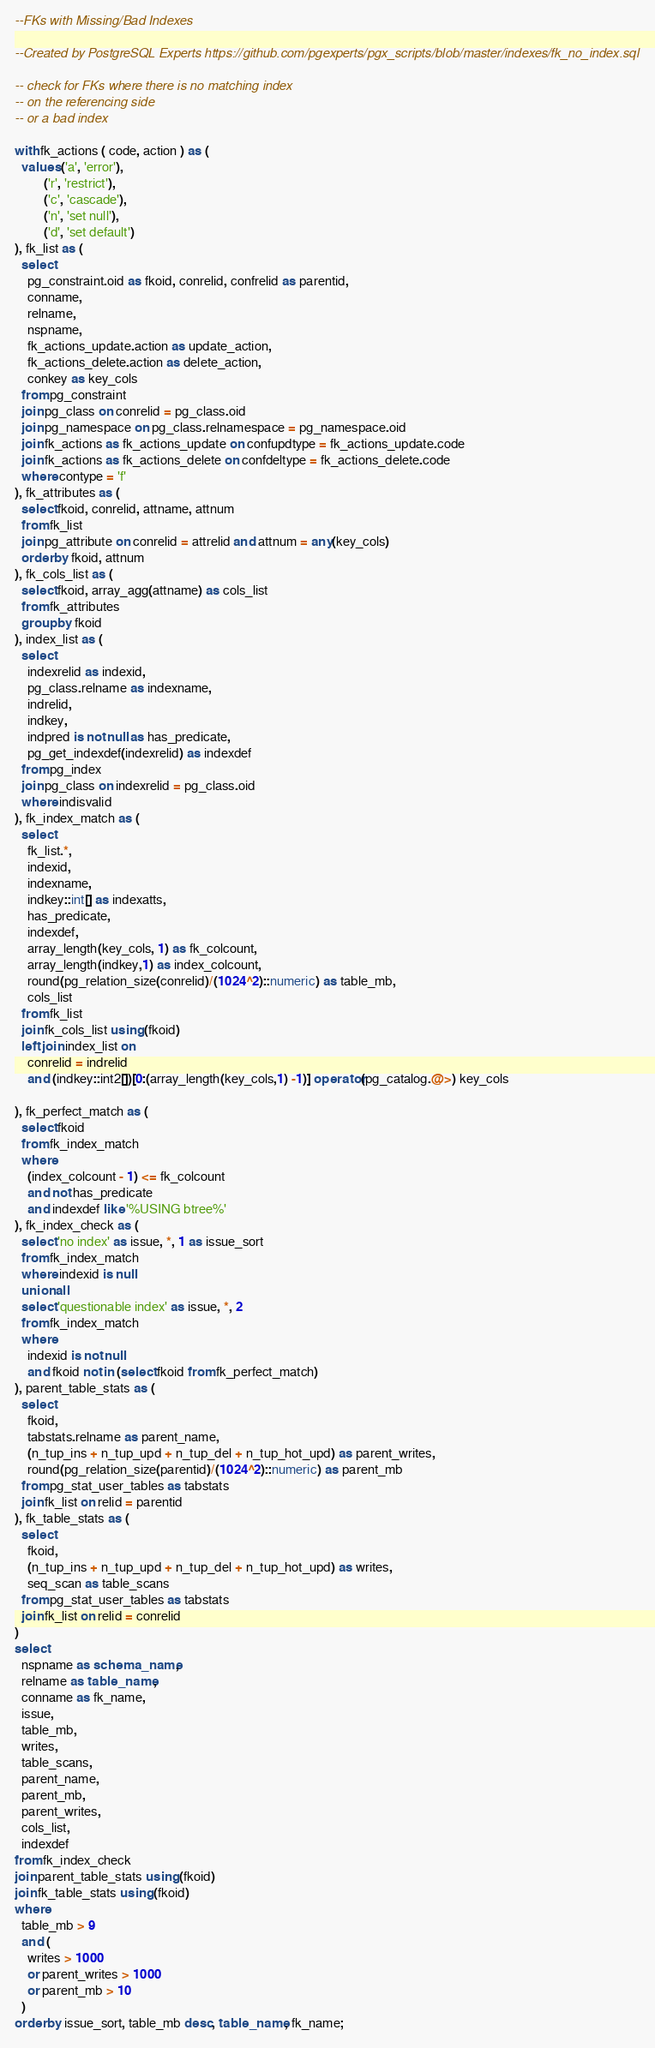Convert code to text. <code><loc_0><loc_0><loc_500><loc_500><_SQL_>--FKs with Missing/Bad Indexes

--Created by PostgreSQL Experts https://github.com/pgexperts/pgx_scripts/blob/master/indexes/fk_no_index.sql

-- check for FKs where there is no matching index
-- on the referencing side
-- or a bad index

with fk_actions ( code, action ) as (
  values ('a', 'error'),
         ('r', 'restrict'),
         ('c', 'cascade'),
         ('n', 'set null'),
         ('d', 'set default')
), fk_list as (
  select
    pg_constraint.oid as fkoid, conrelid, confrelid as parentid,
    conname,
    relname,
    nspname,
    fk_actions_update.action as update_action,
    fk_actions_delete.action as delete_action,
    conkey as key_cols
  from pg_constraint
  join pg_class on conrelid = pg_class.oid
  join pg_namespace on pg_class.relnamespace = pg_namespace.oid
  join fk_actions as fk_actions_update on confupdtype = fk_actions_update.code
  join fk_actions as fk_actions_delete on confdeltype = fk_actions_delete.code
  where contype = 'f'
), fk_attributes as (
  select fkoid, conrelid, attname, attnum
  from fk_list
  join pg_attribute on conrelid = attrelid and attnum = any(key_cols)
  order by fkoid, attnum
), fk_cols_list as (
  select fkoid, array_agg(attname) as cols_list
  from fk_attributes
  group by fkoid
), index_list as (
  select
    indexrelid as indexid,
    pg_class.relname as indexname,
    indrelid,
    indkey,
    indpred is not null as has_predicate,
    pg_get_indexdef(indexrelid) as indexdef
  from pg_index
  join pg_class on indexrelid = pg_class.oid
  where indisvalid
), fk_index_match as (
  select
    fk_list.*,
    indexid,
    indexname,
    indkey::int[] as indexatts,
    has_predicate,
    indexdef,
    array_length(key_cols, 1) as fk_colcount,
    array_length(indkey,1) as index_colcount,
    round(pg_relation_size(conrelid)/(1024^2)::numeric) as table_mb,
    cols_list
  from fk_list
  join fk_cols_list using (fkoid)
  left join index_list on
    conrelid = indrelid
    and (indkey::int2[])[0:(array_length(key_cols,1) -1)] operator(pg_catalog.@>) key_cols

), fk_perfect_match as (
  select fkoid
  from fk_index_match
  where
    (index_colcount - 1) <= fk_colcount
    and not has_predicate
    and indexdef like '%USING btree%'
), fk_index_check as (
  select 'no index' as issue, *, 1 as issue_sort
  from fk_index_match
  where indexid is null
  union all
  select 'questionable index' as issue, *, 2
  from fk_index_match
  where
    indexid is not null
    and fkoid not in (select fkoid from fk_perfect_match)
), parent_table_stats as (
  select
    fkoid,
    tabstats.relname as parent_name,
    (n_tup_ins + n_tup_upd + n_tup_del + n_tup_hot_upd) as parent_writes,
    round(pg_relation_size(parentid)/(1024^2)::numeric) as parent_mb
  from pg_stat_user_tables as tabstats
  join fk_list on relid = parentid
), fk_table_stats as (
  select
    fkoid,
    (n_tup_ins + n_tup_upd + n_tup_del + n_tup_hot_upd) as writes,
    seq_scan as table_scans
  from pg_stat_user_tables as tabstats
  join fk_list on relid = conrelid
)
select
  nspname as schema_name,
  relname as table_name,
  conname as fk_name,
  issue,
  table_mb,
  writes,
  table_scans,
  parent_name,
  parent_mb,
  parent_writes,
  cols_list,
  indexdef
from fk_index_check
join parent_table_stats using (fkoid)
join fk_table_stats using (fkoid)
where
  table_mb > 9
  and (
    writes > 1000
    or parent_writes > 1000
    or parent_mb > 10
  )
order by issue_sort, table_mb desc, table_name, fk_name;
</code> 